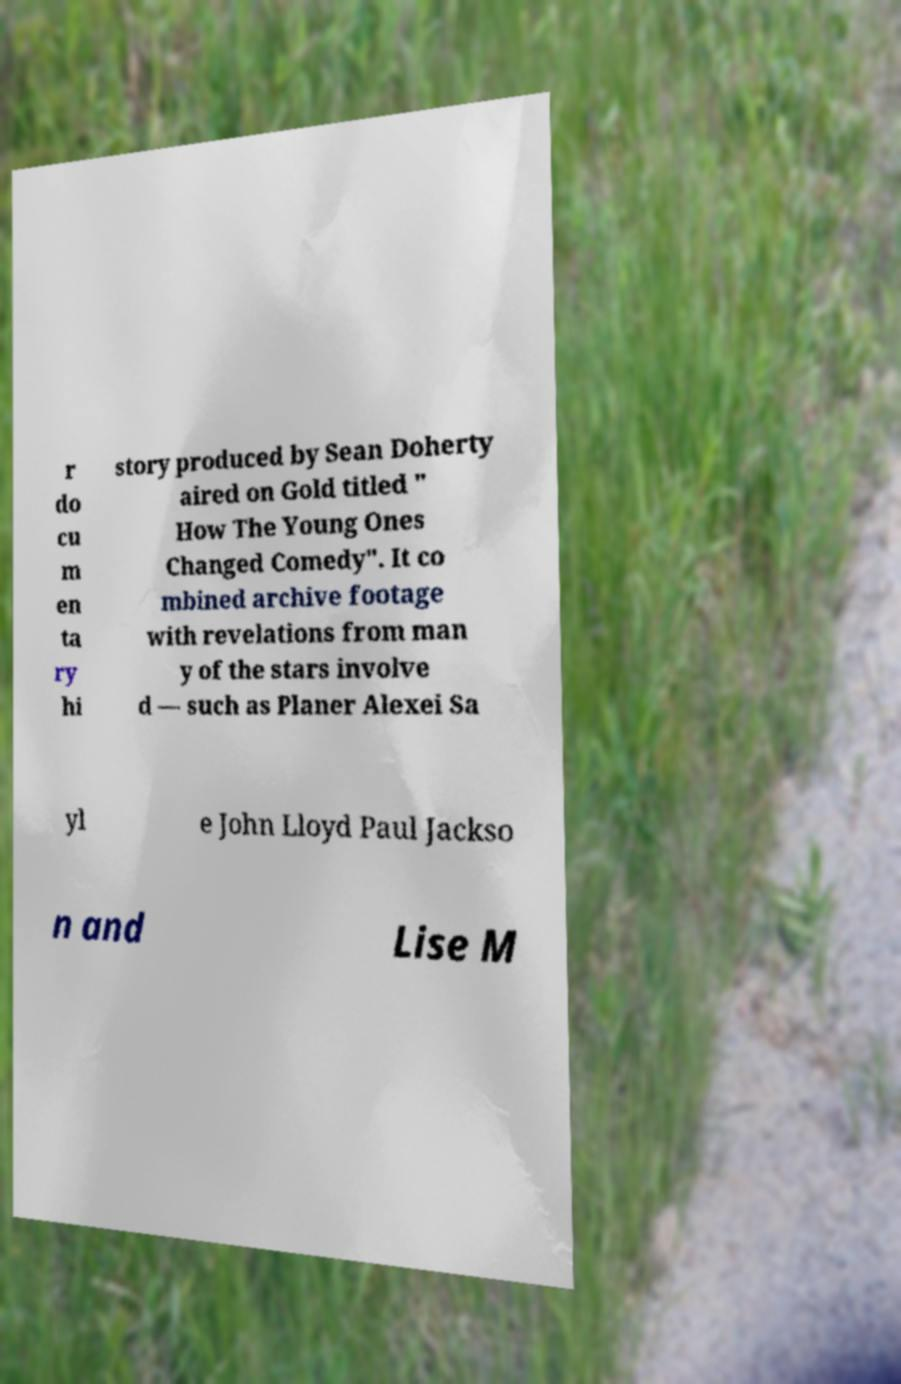Please identify and transcribe the text found in this image. r do cu m en ta ry hi story produced by Sean Doherty aired on Gold titled " How The Young Ones Changed Comedy". It co mbined archive footage with revelations from man y of the stars involve d — such as Planer Alexei Sa yl e John Lloyd Paul Jackso n and Lise M 